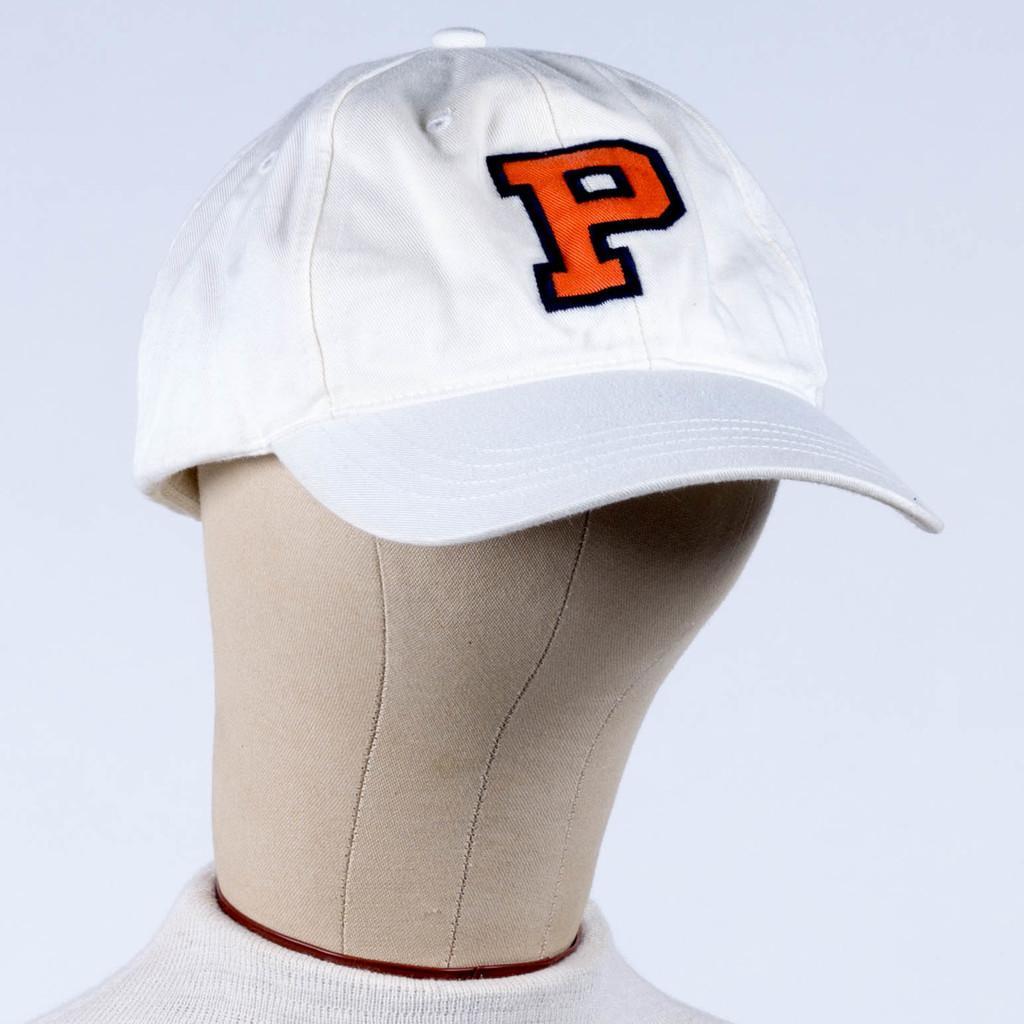Please provide a concise description of this image. In this image we can see there is a toy wearing cap. 